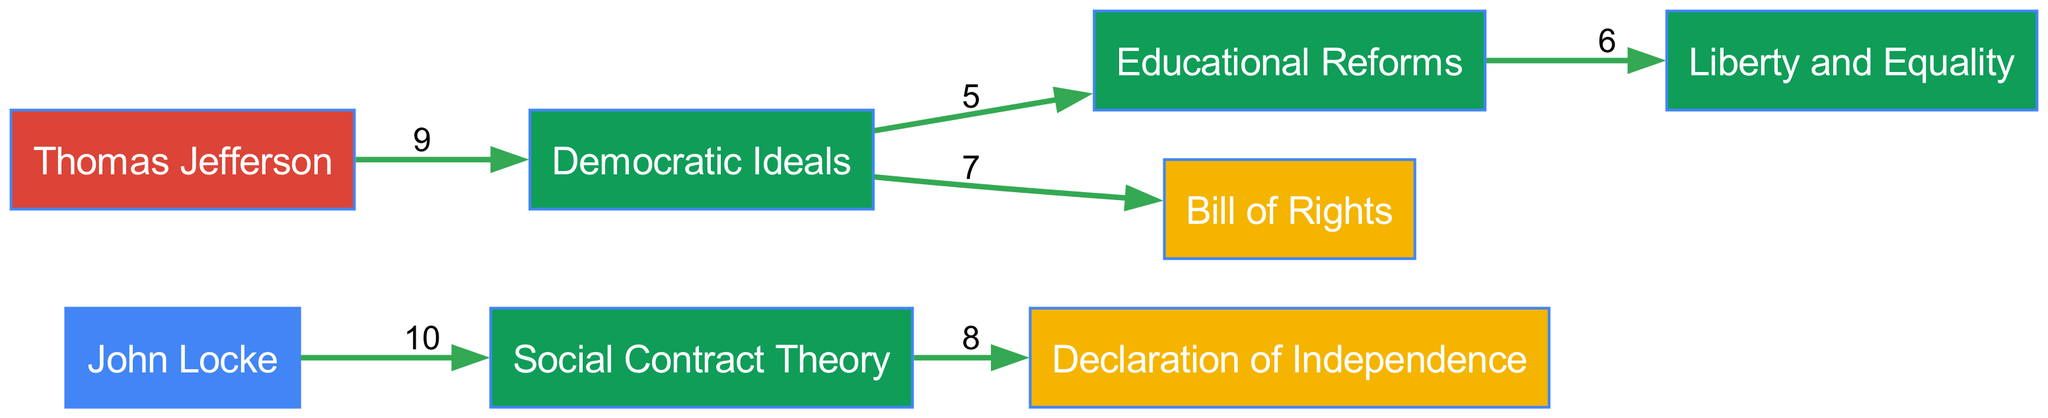What concept is John Locke associated with? According to the diagram, a direct link originates from John Locke to the Social Contract Theory. The value assigned to this link is 10, indicating a strong association.
Answer: Social Contract Theory How many nodes are in the diagram? By counting the entries in the nodes section of the diagram data, we see there are a total of 8 nodes representing various philosophers, concepts, documents, and events.
Answer: 8 Which document is directly linked to Social Contract Theory? The diagram indicates that there is a direct connection from the Social Contract Theory node to the Declaration of Independence, with a value of 8 representing this relationship.
Answer: Declaration of Independence What is the value of the link between Democratic Ideals and Educational Reforms? The link between the Democratic Ideals and Educational Reforms is represented in the diagram as having a value of 5, indicating a moderate level of influence or connection between these two nodes.
Answer: 5 Who contributed to the concept of Democratic Ideals? The diagram shows that Thomas Jefferson is the source node that links to the concept of Democratic Ideals with a value of 9, highlighting his significant contribution to these ideals.
Answer: Thomas Jefferson Which linkage shows the least value in the diagram? Inspecting the links in the diagram, the one connecting Educational Reforms to Liberty and Equality has the lowest value of 6 compared to other connections, indicating a weaker association.
Answer: Educational Reforms to Liberty and Equality What are the two concepts that flow from Democratic Ideals? The diagram visually depicts two outgoing connections from the Democratic Ideals node: one to the Bill of Rights with a value of 7, and another to Educational Reforms with a value of 5, indicating the multiple influences that stem from this concept.
Answer: Bill of Rights and Educational Reforms What type of nodes does the node "Bill of Rights" belong to? The diagram categorizes nodes into types based on their function, and the Bill of Rights is classified as a Document, which is verified from its entry in the nodes list.
Answer: Document How many concepts are illustrated in the diagram? By analyzing the nodes section, there are three nodes classified as concepts: Social Contract Theory, Democratic Ideals, and Liberty and Equality. Counting these examples gives a total of 3 concepts present.
Answer: 3 